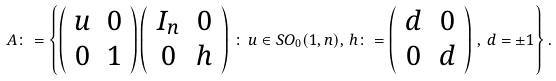Convert formula to latex. <formula><loc_0><loc_0><loc_500><loc_500>A \colon = \left \{ \left ( \begin{array} { c c } u & 0 \\ 0 & 1 \end{array} \right ) \left ( \begin{array} { c c } I _ { n } & 0 \\ 0 & h \end{array} \right ) \, \colon \, u \in S O _ { 0 } ( 1 , n ) , \, h \colon = \left ( \begin{array} { c c } d & 0 \\ 0 & d \end{array} \right ) \, , \, d = \pm 1 \right \} .</formula> 